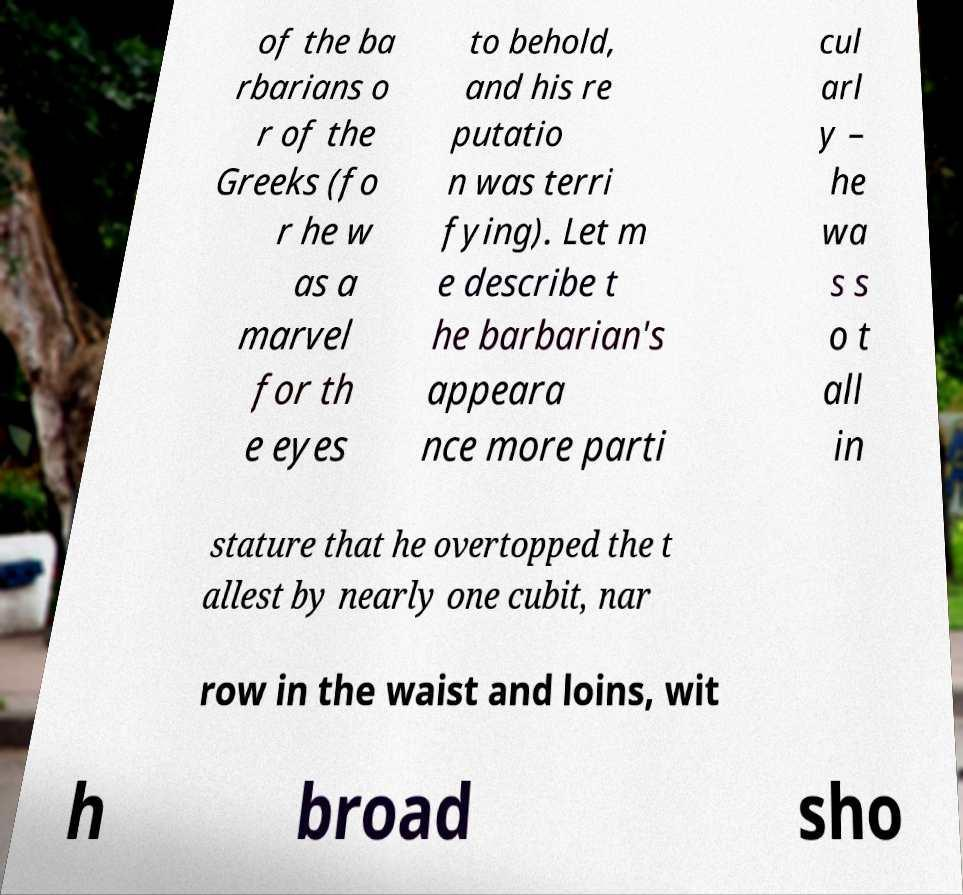Could you extract and type out the text from this image? of the ba rbarians o r of the Greeks (fo r he w as a marvel for th e eyes to behold, and his re putatio n was terri fying). Let m e describe t he barbarian's appeara nce more parti cul arl y – he wa s s o t all in stature that he overtopped the t allest by nearly one cubit, nar row in the waist and loins, wit h broad sho 